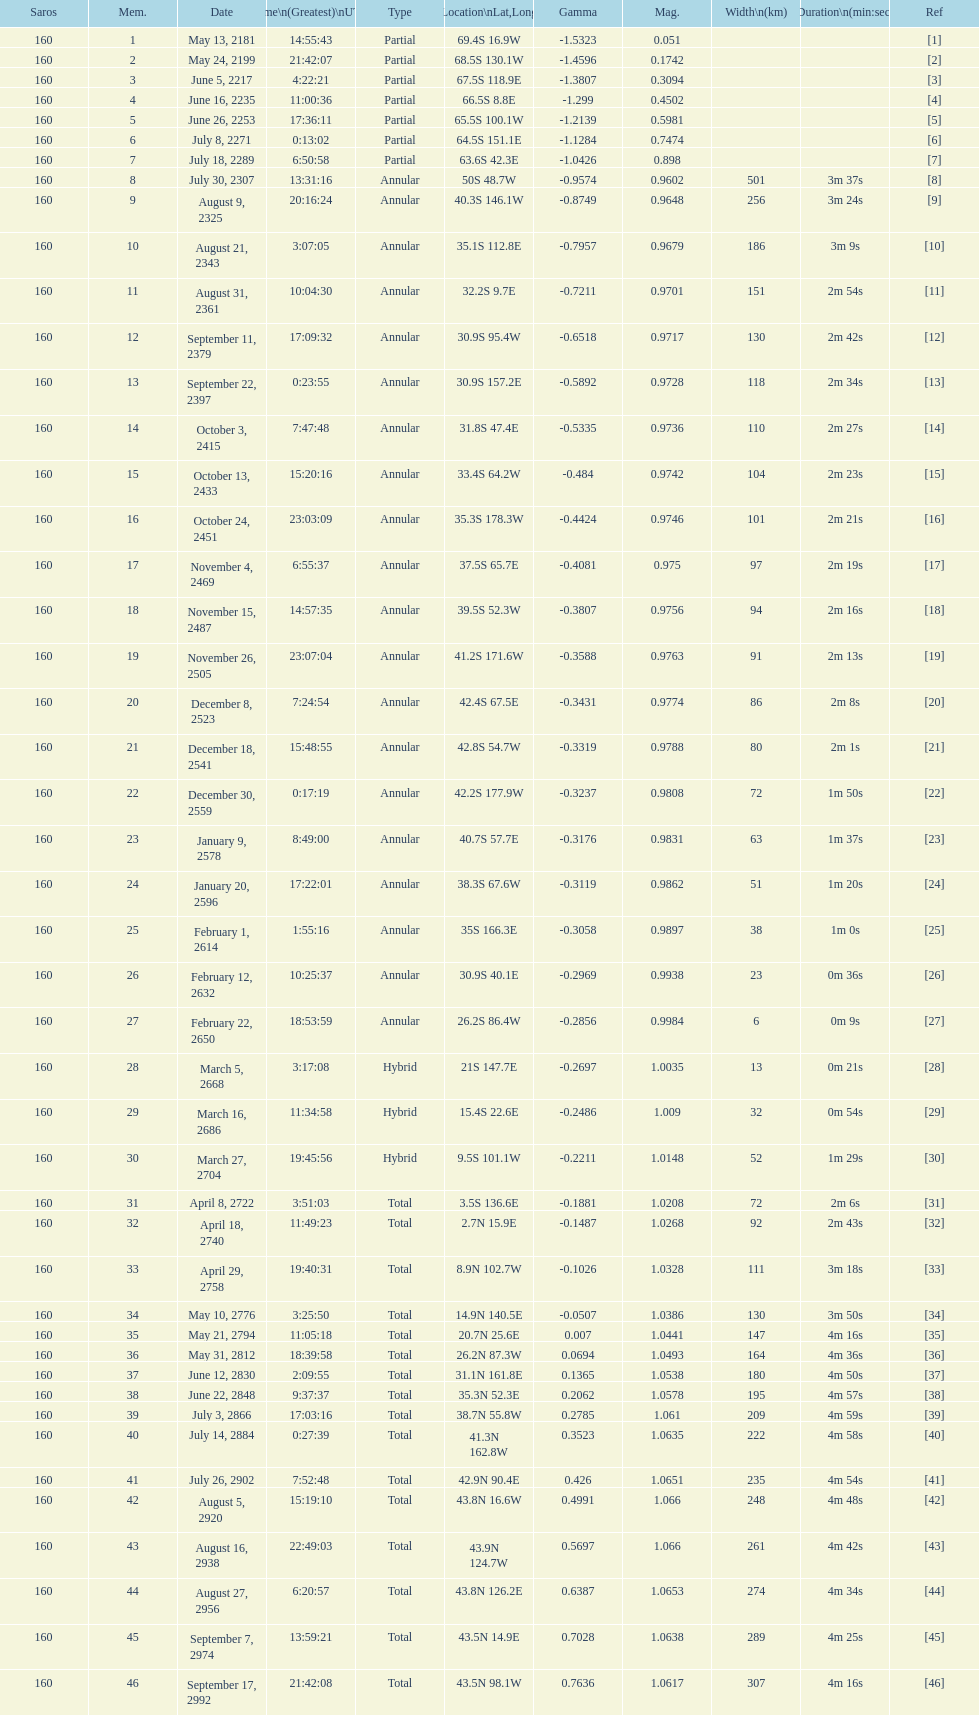How many partial members will occur before the first annular? 7. 